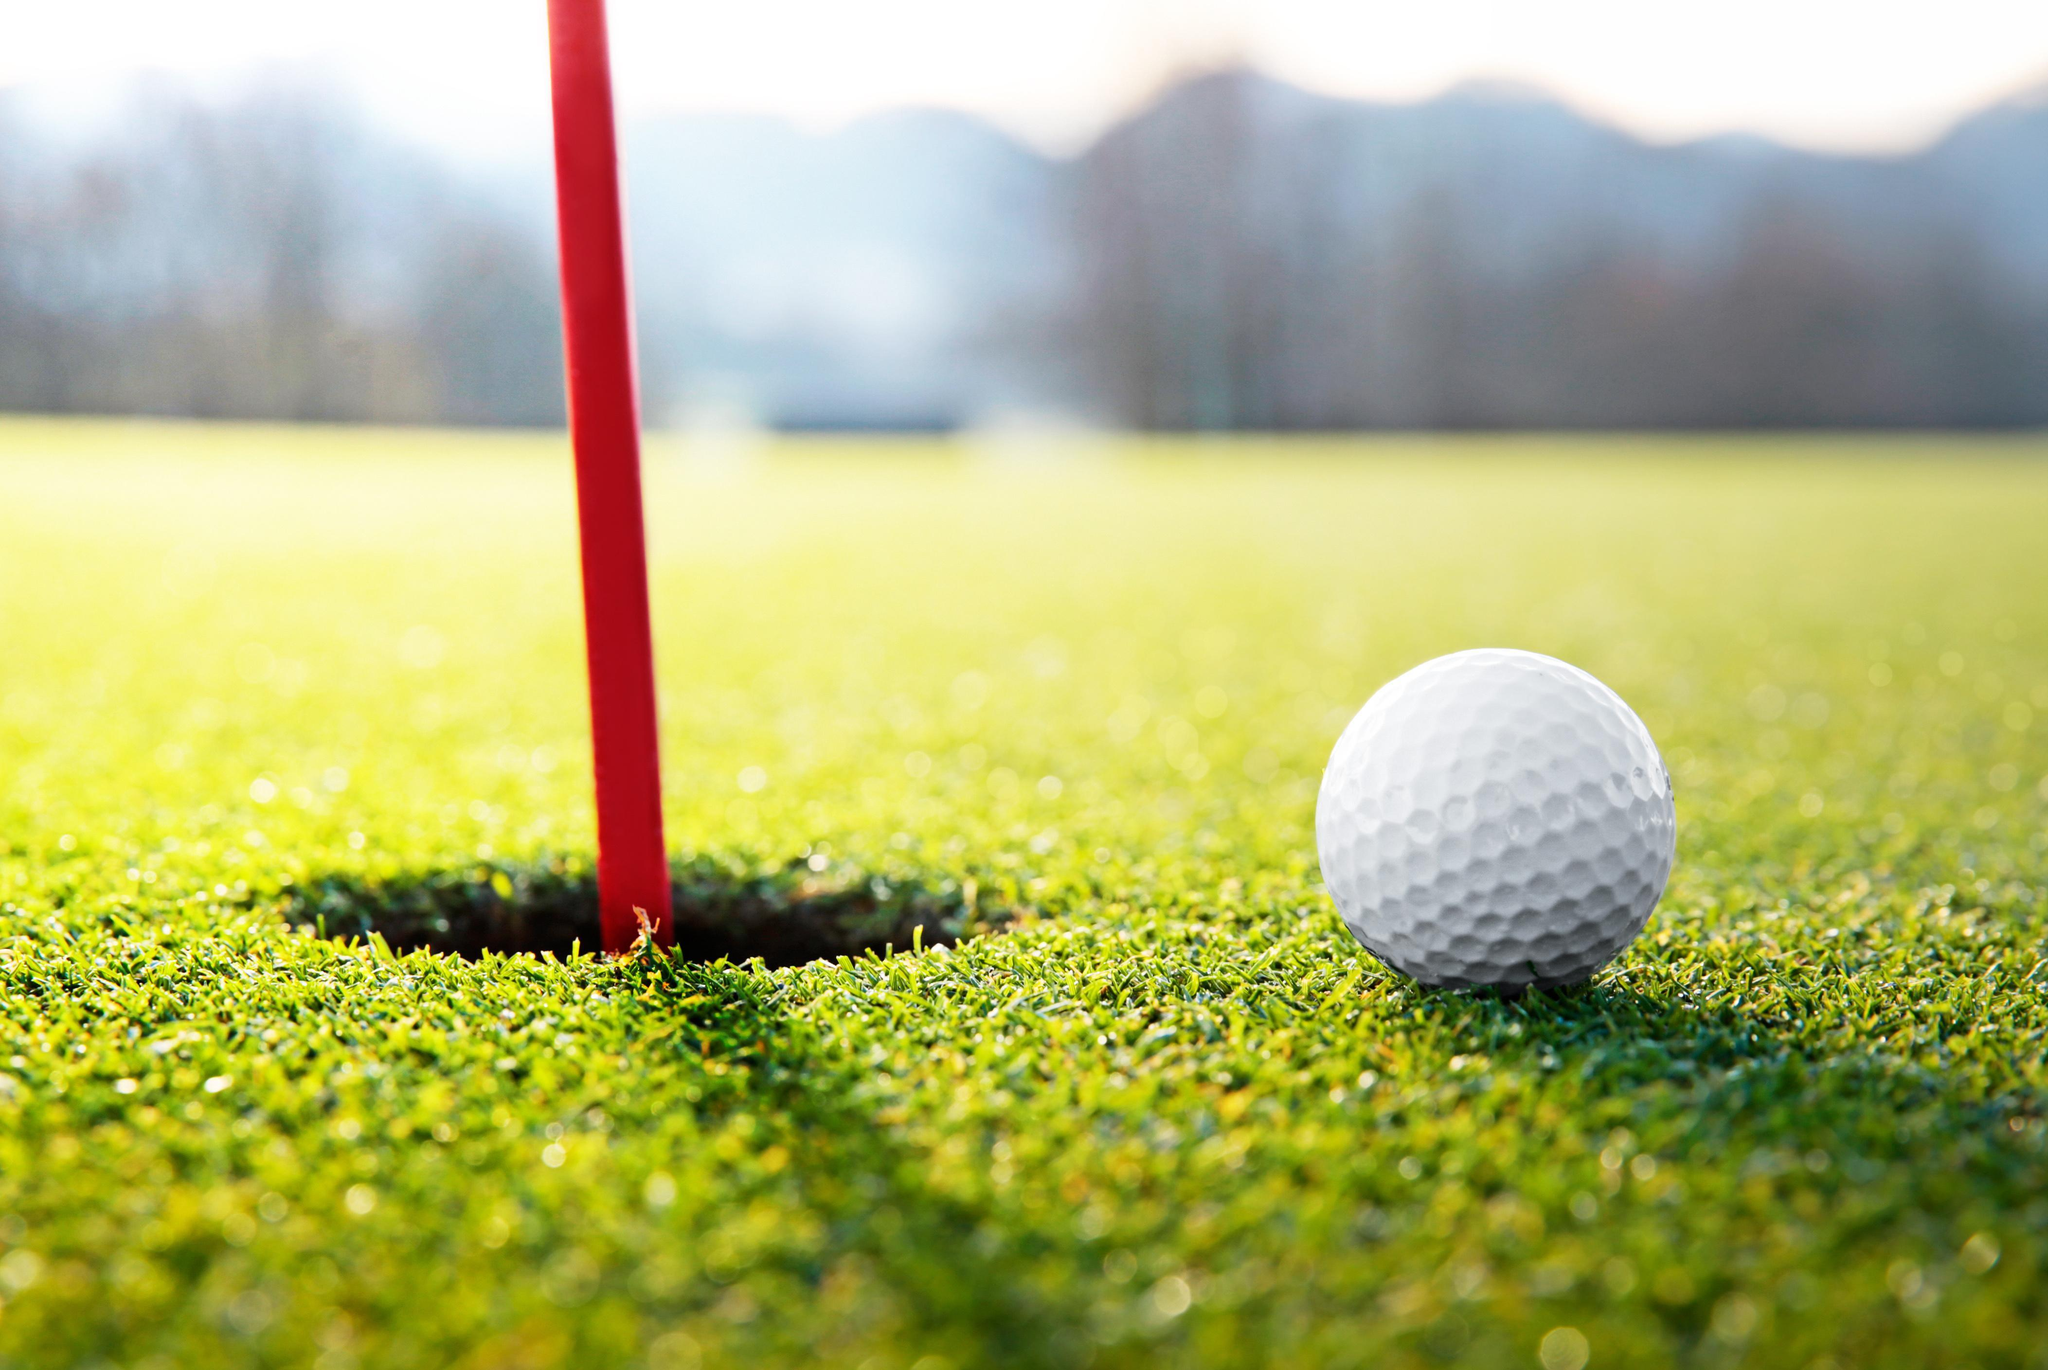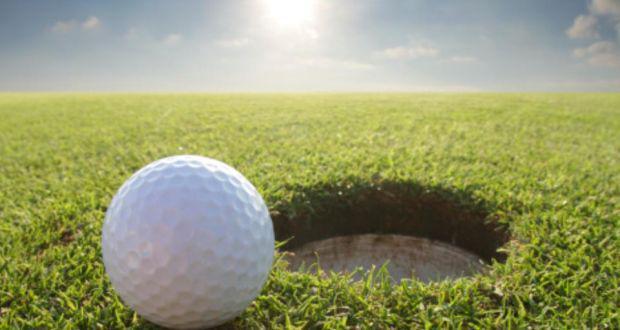The first image is the image on the left, the second image is the image on the right. Evaluate the accuracy of this statement regarding the images: "There is a ball near the hole in at least one of the images.". Is it true? Answer yes or no. Yes. The first image is the image on the left, the second image is the image on the right. Given the left and right images, does the statement "An image shows one golf ball next to a hole that does not have a pole in it." hold true? Answer yes or no. Yes. 